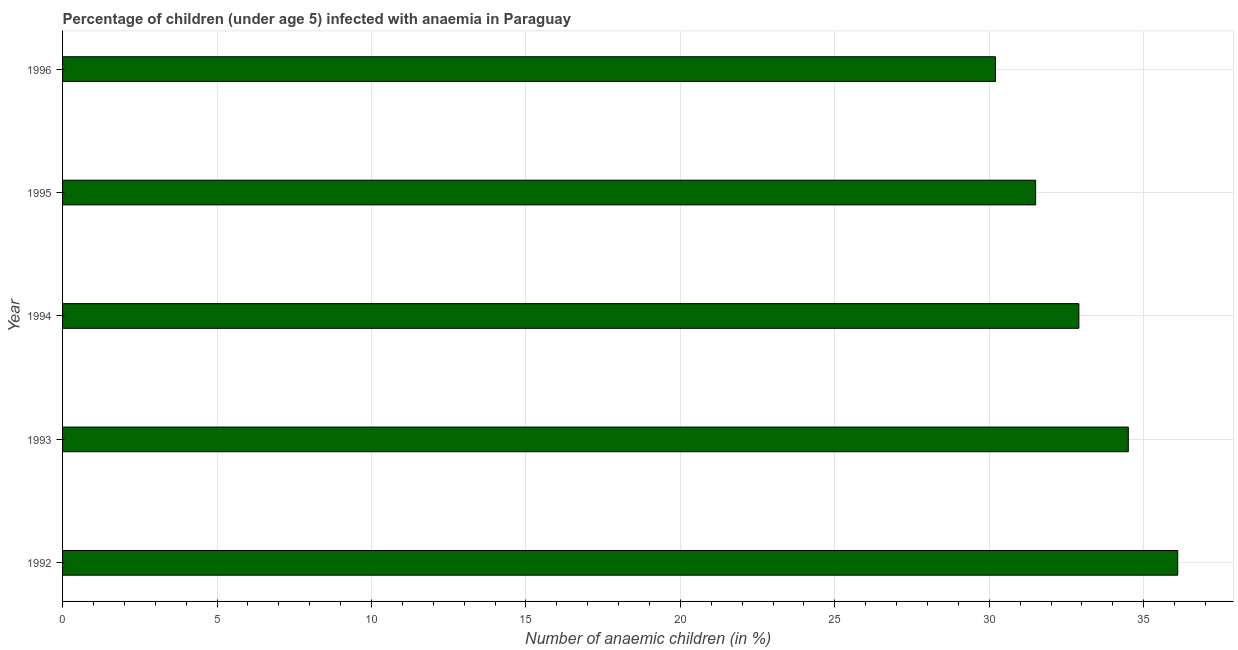Does the graph contain grids?
Your answer should be very brief. Yes. What is the title of the graph?
Offer a terse response. Percentage of children (under age 5) infected with anaemia in Paraguay. What is the label or title of the X-axis?
Offer a terse response. Number of anaemic children (in %). What is the number of anaemic children in 1992?
Offer a very short reply. 36.1. Across all years, what is the maximum number of anaemic children?
Your response must be concise. 36.1. Across all years, what is the minimum number of anaemic children?
Ensure brevity in your answer.  30.2. In which year was the number of anaemic children maximum?
Offer a very short reply. 1992. In which year was the number of anaemic children minimum?
Your answer should be compact. 1996. What is the sum of the number of anaemic children?
Your answer should be compact. 165.2. What is the difference between the number of anaemic children in 1995 and 1996?
Offer a very short reply. 1.3. What is the average number of anaemic children per year?
Your answer should be compact. 33.04. What is the median number of anaemic children?
Offer a very short reply. 32.9. What is the ratio of the number of anaemic children in 1992 to that in 1993?
Make the answer very short. 1.05. Is the number of anaemic children in 1994 less than that in 1995?
Provide a short and direct response. No. What is the difference between the highest and the second highest number of anaemic children?
Make the answer very short. 1.6. Is the sum of the number of anaemic children in 1994 and 1996 greater than the maximum number of anaemic children across all years?
Provide a short and direct response. Yes. What is the difference between the highest and the lowest number of anaemic children?
Make the answer very short. 5.9. In how many years, is the number of anaemic children greater than the average number of anaemic children taken over all years?
Offer a terse response. 2. What is the difference between two consecutive major ticks on the X-axis?
Your answer should be compact. 5. Are the values on the major ticks of X-axis written in scientific E-notation?
Offer a very short reply. No. What is the Number of anaemic children (in %) of 1992?
Your response must be concise. 36.1. What is the Number of anaemic children (in %) in 1993?
Offer a terse response. 34.5. What is the Number of anaemic children (in %) in 1994?
Offer a terse response. 32.9. What is the Number of anaemic children (in %) in 1995?
Your response must be concise. 31.5. What is the Number of anaemic children (in %) in 1996?
Provide a succinct answer. 30.2. What is the difference between the Number of anaemic children (in %) in 1992 and 1993?
Provide a succinct answer. 1.6. What is the difference between the Number of anaemic children (in %) in 1992 and 1994?
Your response must be concise. 3.2. What is the difference between the Number of anaemic children (in %) in 1992 and 1996?
Keep it short and to the point. 5.9. What is the difference between the Number of anaemic children (in %) in 1993 and 1995?
Give a very brief answer. 3. What is the difference between the Number of anaemic children (in %) in 1993 and 1996?
Your answer should be very brief. 4.3. What is the ratio of the Number of anaemic children (in %) in 1992 to that in 1993?
Your answer should be very brief. 1.05. What is the ratio of the Number of anaemic children (in %) in 1992 to that in 1994?
Keep it short and to the point. 1.1. What is the ratio of the Number of anaemic children (in %) in 1992 to that in 1995?
Make the answer very short. 1.15. What is the ratio of the Number of anaemic children (in %) in 1992 to that in 1996?
Give a very brief answer. 1.2. What is the ratio of the Number of anaemic children (in %) in 1993 to that in 1994?
Make the answer very short. 1.05. What is the ratio of the Number of anaemic children (in %) in 1993 to that in 1995?
Give a very brief answer. 1.09. What is the ratio of the Number of anaemic children (in %) in 1993 to that in 1996?
Your answer should be compact. 1.14. What is the ratio of the Number of anaemic children (in %) in 1994 to that in 1995?
Give a very brief answer. 1.04. What is the ratio of the Number of anaemic children (in %) in 1994 to that in 1996?
Offer a very short reply. 1.09. What is the ratio of the Number of anaemic children (in %) in 1995 to that in 1996?
Provide a succinct answer. 1.04. 